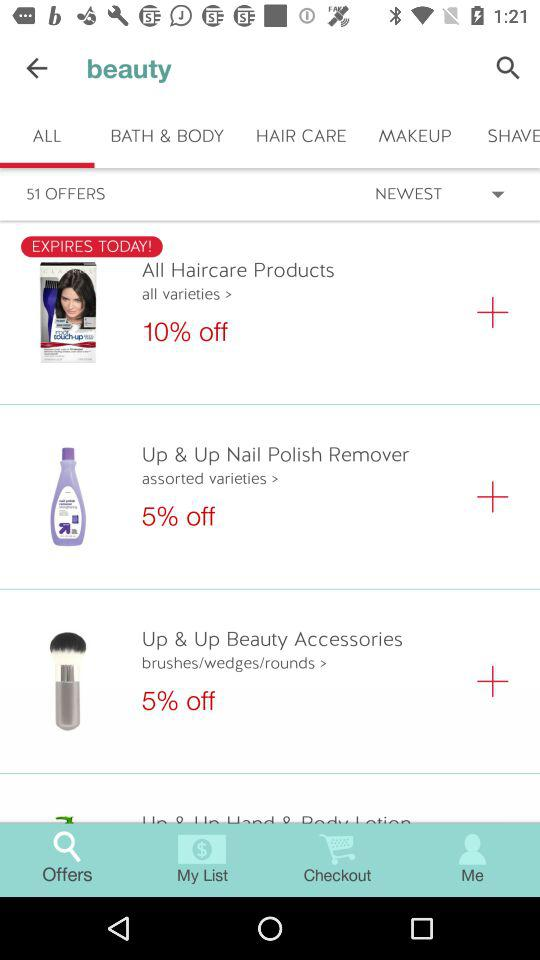How much is offered on "All Haircare Products"? The offer on "All Haircare Products" is 10%. 